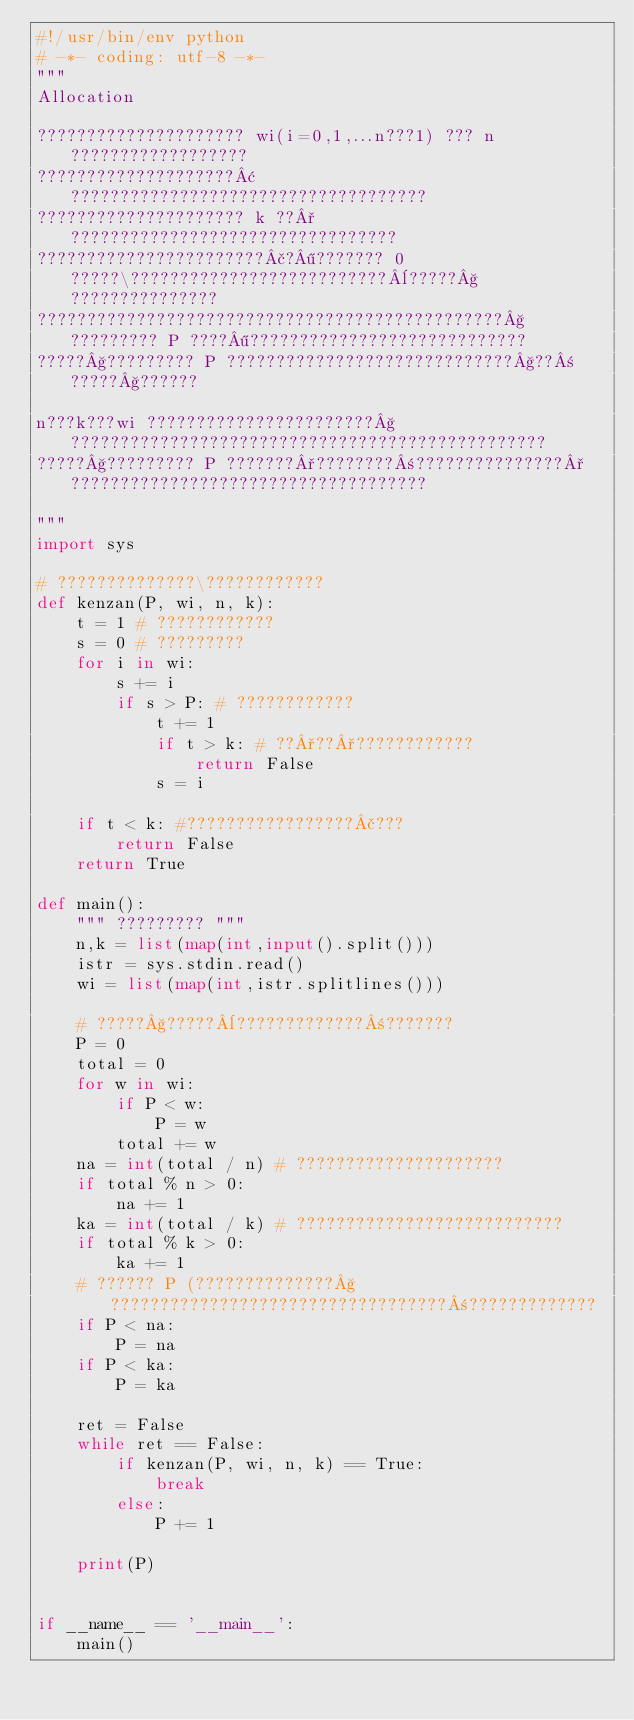<code> <loc_0><loc_0><loc_500><loc_500><_Python_>#!/usr/bin/env python
# -*- coding: utf-8 -*-
"""
Allocation

????????????????????? wi(i=0,1,...n???1) ??? n ??????????????????
????????????????????¢????????????????????????????????????
????????????????????? k ??°?????????????????????????????????
???????????????????????£?¶??????? 0 ?????\??????????????????????????¨?????§???????????????
???????????????????????????????????????????????§????????? P ????¶????????????????????????????
?????§????????? P ?????????????????????????????§??±?????§??????

n???k???wi ???????????????????????§????????????????????????????????????????????????
?????§????????? P ???????°????????±???????????????°????????????????????????????????????

"""
import sys

# ??????????????\????????????
def kenzan(P, wi, n, k):
    t = 1 # ????????????
    s = 0 # ?????????
    for i in wi:
        s += i
        if s > P: # ????????????
            t += 1
            if t > k: # ??°??°????????????
                return False
            s = i
    
    if t < k: #?????????????????£???
        return False
    return True

def main():
    """ ????????? """
    n,k = list(map(int,input().split()))
    istr = sys.stdin.read()
    wi = list(map(int,istr.splitlines()))

    # ?????§?????¨?????????????±???????
    P = 0
    total = 0
    for w in wi:
        if P < w:
            P = w
        total += w
    na = int(total / n) # ?????????????????????
    if total % n > 0:
        na += 1
    ka = int(total / k) # ???????????????????????????
    if total % k > 0:
        ka += 1
    # ?????? P (??????????????§??????????????????????????????????±?????????????
    if P < na:
        P = na
    if P < ka:
        P = ka

    ret = False
    while ret == False:
        if kenzan(P, wi, n, k) == True:
            break
        else:
            P += 1

    print(P)


if __name__ == '__main__':
    main()</code> 